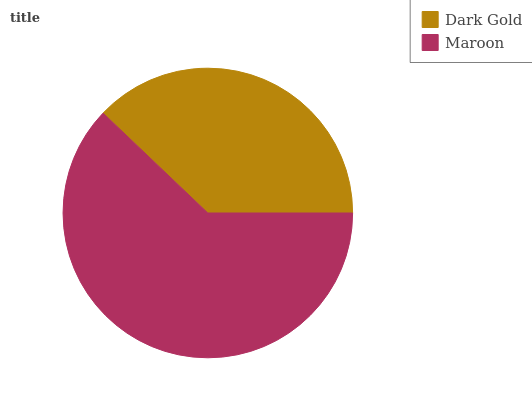Is Dark Gold the minimum?
Answer yes or no. Yes. Is Maroon the maximum?
Answer yes or no. Yes. Is Maroon the minimum?
Answer yes or no. No. Is Maroon greater than Dark Gold?
Answer yes or no. Yes. Is Dark Gold less than Maroon?
Answer yes or no. Yes. Is Dark Gold greater than Maroon?
Answer yes or no. No. Is Maroon less than Dark Gold?
Answer yes or no. No. Is Maroon the high median?
Answer yes or no. Yes. Is Dark Gold the low median?
Answer yes or no. Yes. Is Dark Gold the high median?
Answer yes or no. No. Is Maroon the low median?
Answer yes or no. No. 